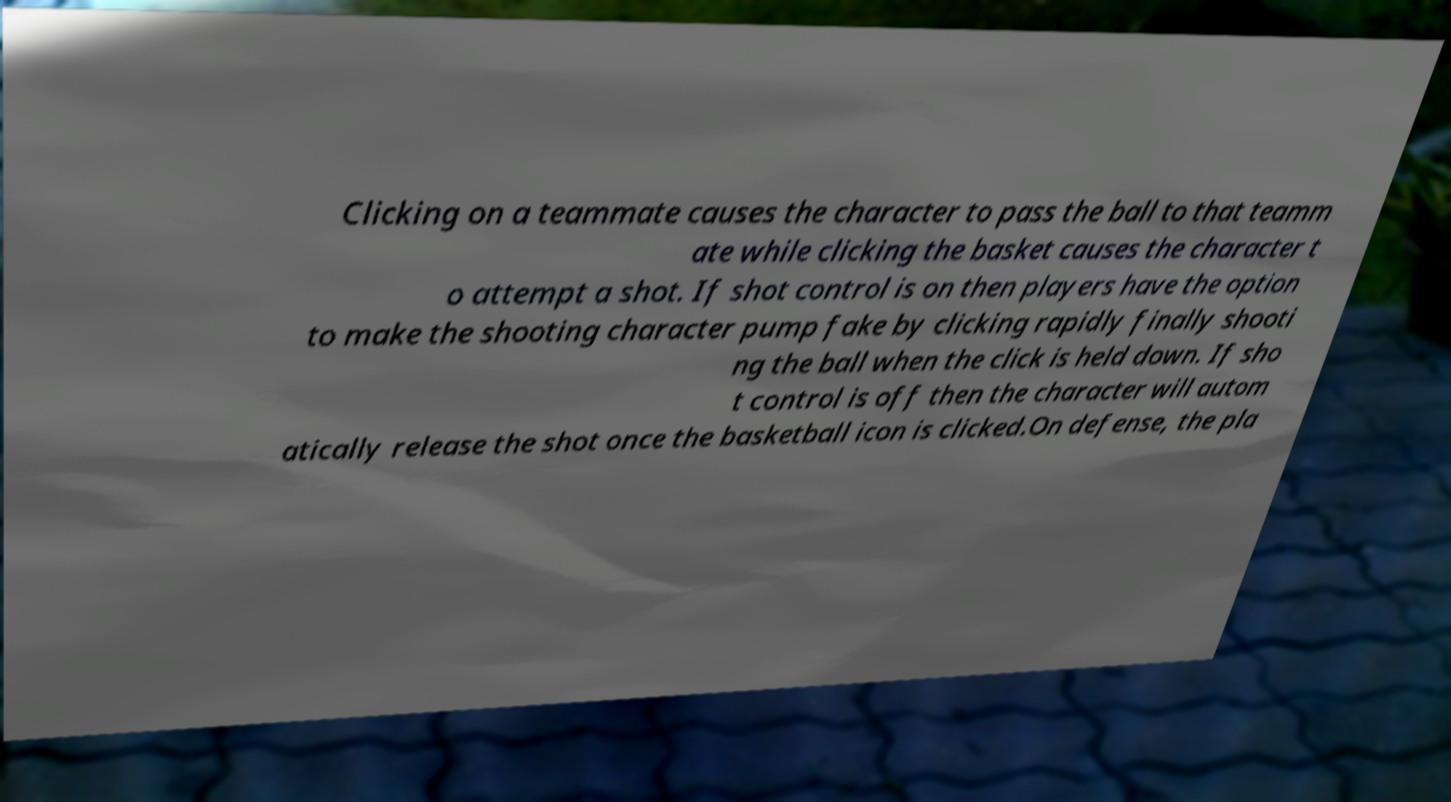Please read and relay the text visible in this image. What does it say? Clicking on a teammate causes the character to pass the ball to that teamm ate while clicking the basket causes the character t o attempt a shot. If shot control is on then players have the option to make the shooting character pump fake by clicking rapidly finally shooti ng the ball when the click is held down. If sho t control is off then the character will autom atically release the shot once the basketball icon is clicked.On defense, the pla 